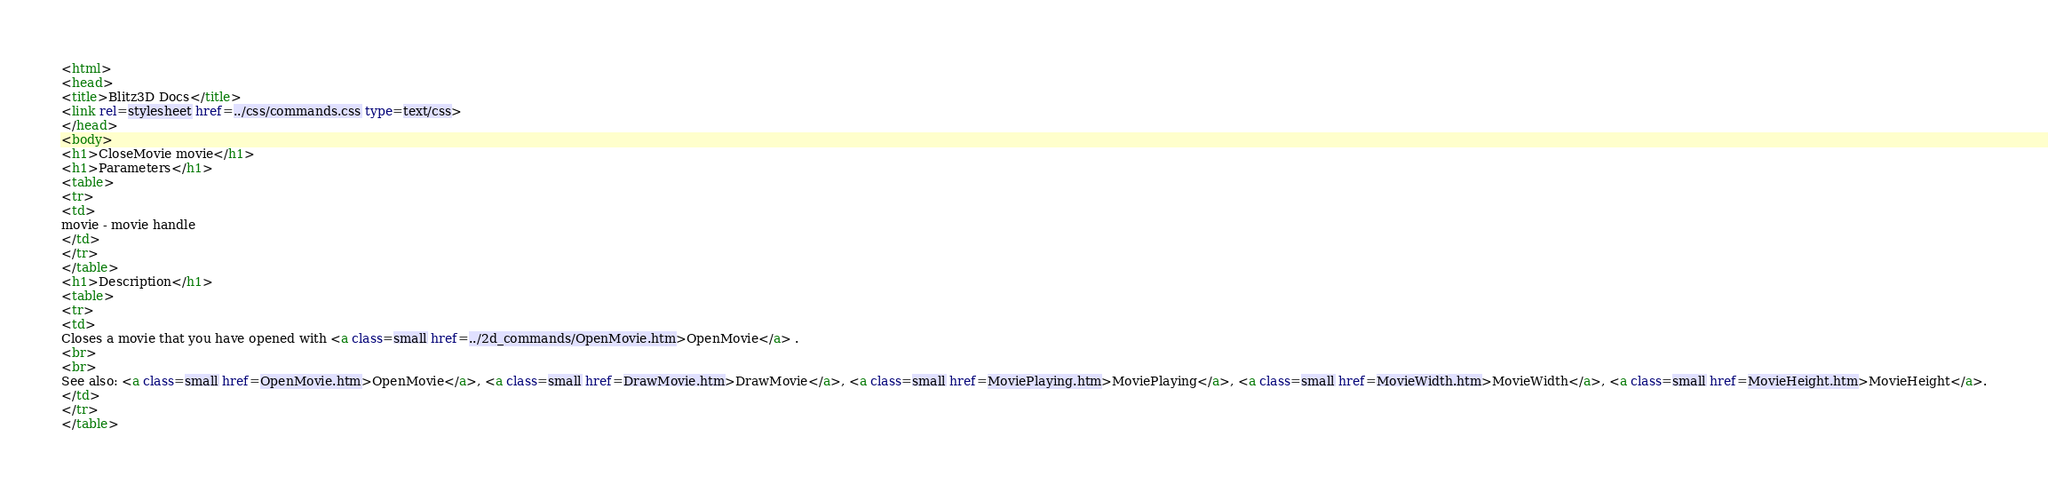<code> <loc_0><loc_0><loc_500><loc_500><_HTML_><html>
<head>
<title>Blitz3D Docs</title>
<link rel=stylesheet href=../css/commands.css type=text/css>
</head>
<body>
<h1>CloseMovie movie</h1>
<h1>Parameters</h1>
<table>
<tr>
<td>
movie - movie handle
</td>
</tr>
</table>
<h1>Description</h1>
<table>
<tr>
<td>
Closes a movie that you have opened with <a class=small href=../2d_commands/OpenMovie.htm>OpenMovie</a> .
<br>
<br>
See also: <a class=small href=OpenMovie.htm>OpenMovie</a>, <a class=small href=DrawMovie.htm>DrawMovie</a>, <a class=small href=MoviePlaying.htm>MoviePlaying</a>, <a class=small href=MovieWidth.htm>MovieWidth</a>, <a class=small href=MovieHeight.htm>MovieHeight</a>.
</td>
</tr>
</table></code> 